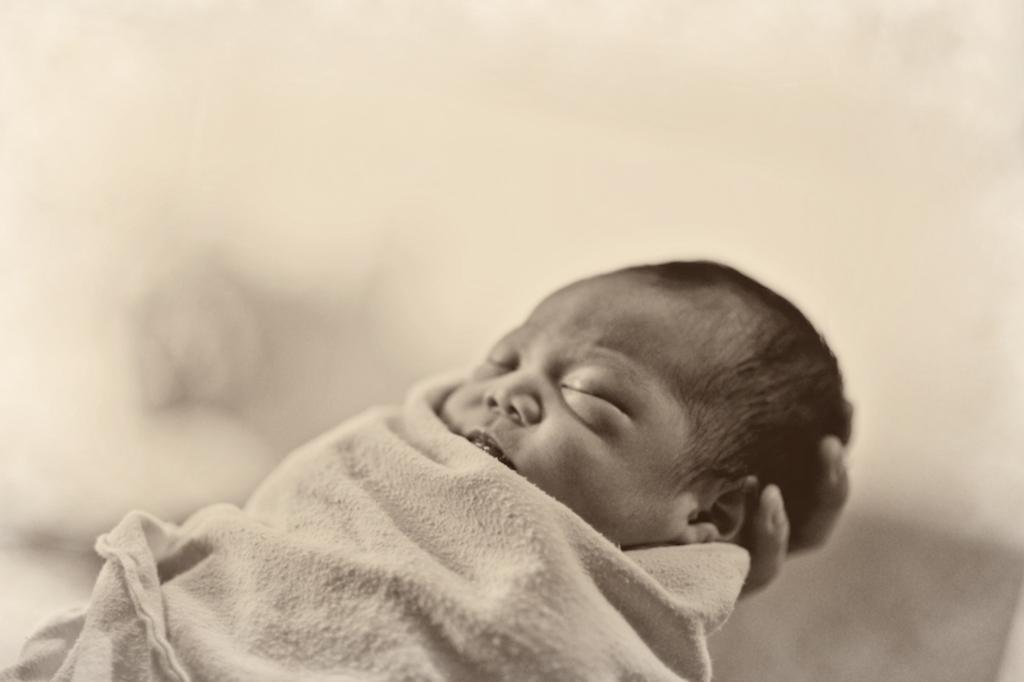What is the main subject of the image? There is a baby in the image. Where is the baby located in the image? The baby is on a person's hand. Can you describe the background of the image? The background of the image is blurry. What flavor of ice cream is being served on the stage in the image? There is no stage or ice cream present in the image; it features a baby on a person's hand with a blurry background. 